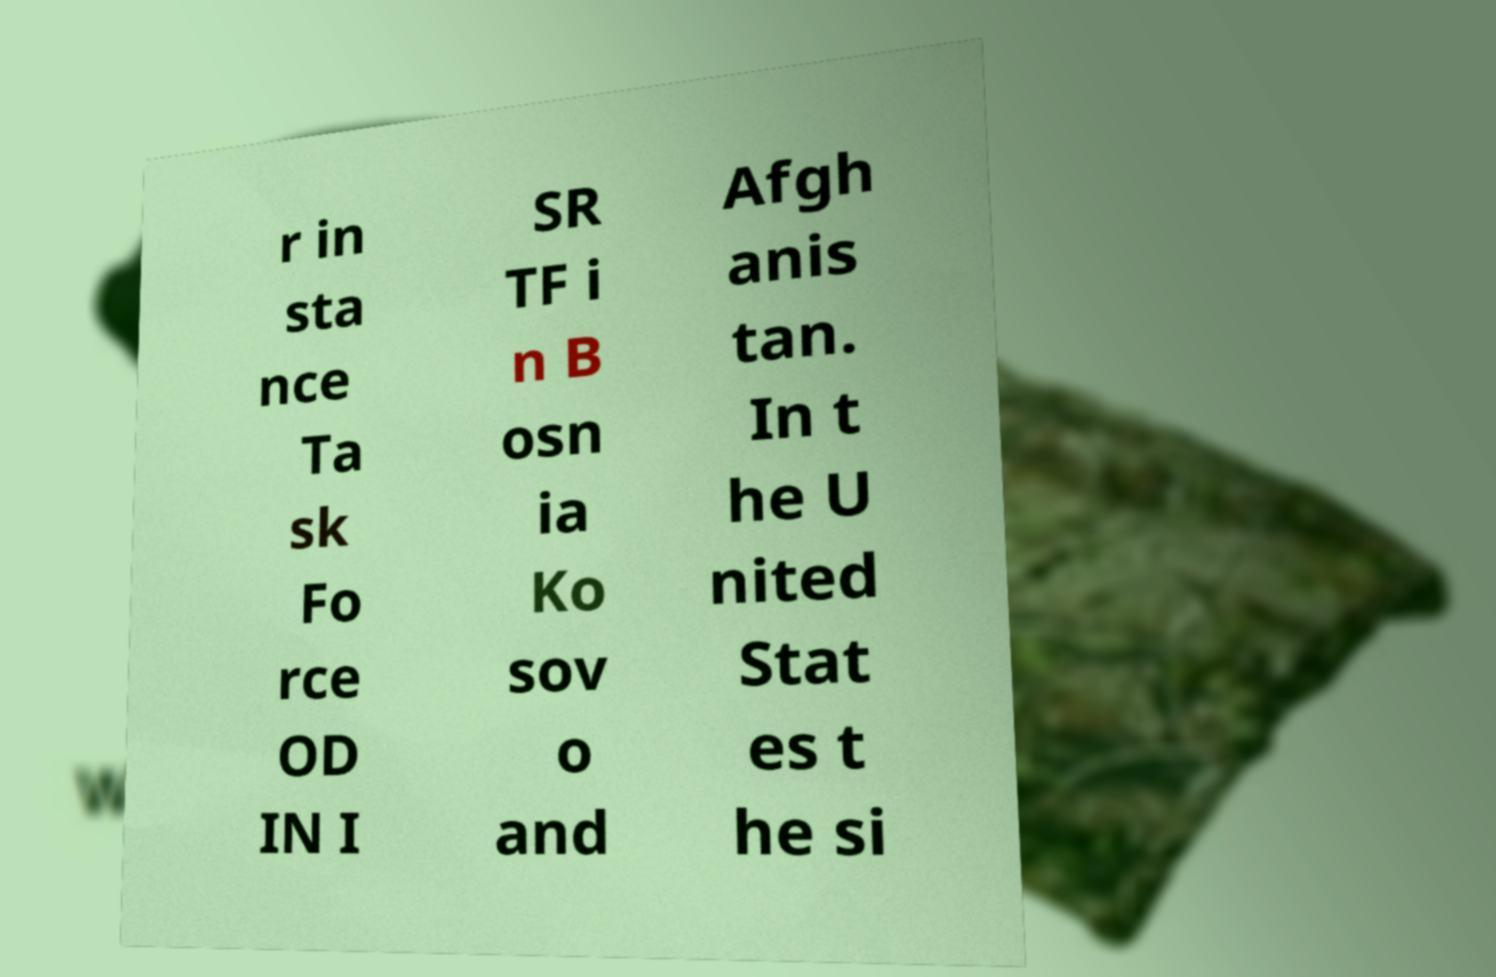Can you accurately transcribe the text from the provided image for me? r in sta nce Ta sk Fo rce OD IN I SR TF i n B osn ia Ko sov o and Afgh anis tan. In t he U nited Stat es t he si 